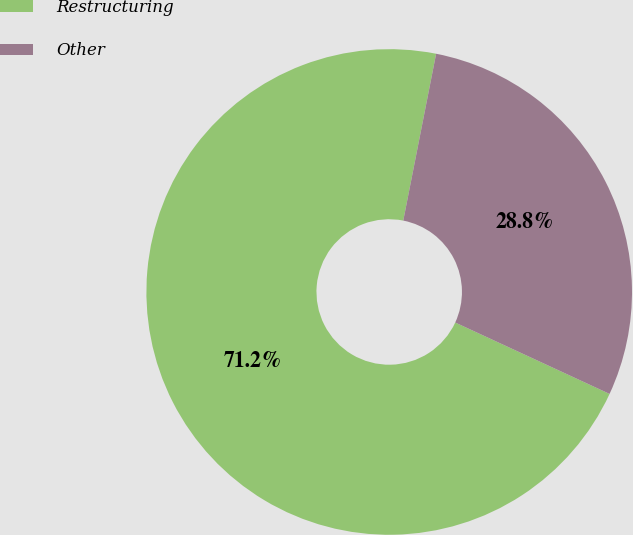Convert chart to OTSL. <chart><loc_0><loc_0><loc_500><loc_500><pie_chart><fcel>Restructuring<fcel>Other<nl><fcel>71.2%<fcel>28.8%<nl></chart> 